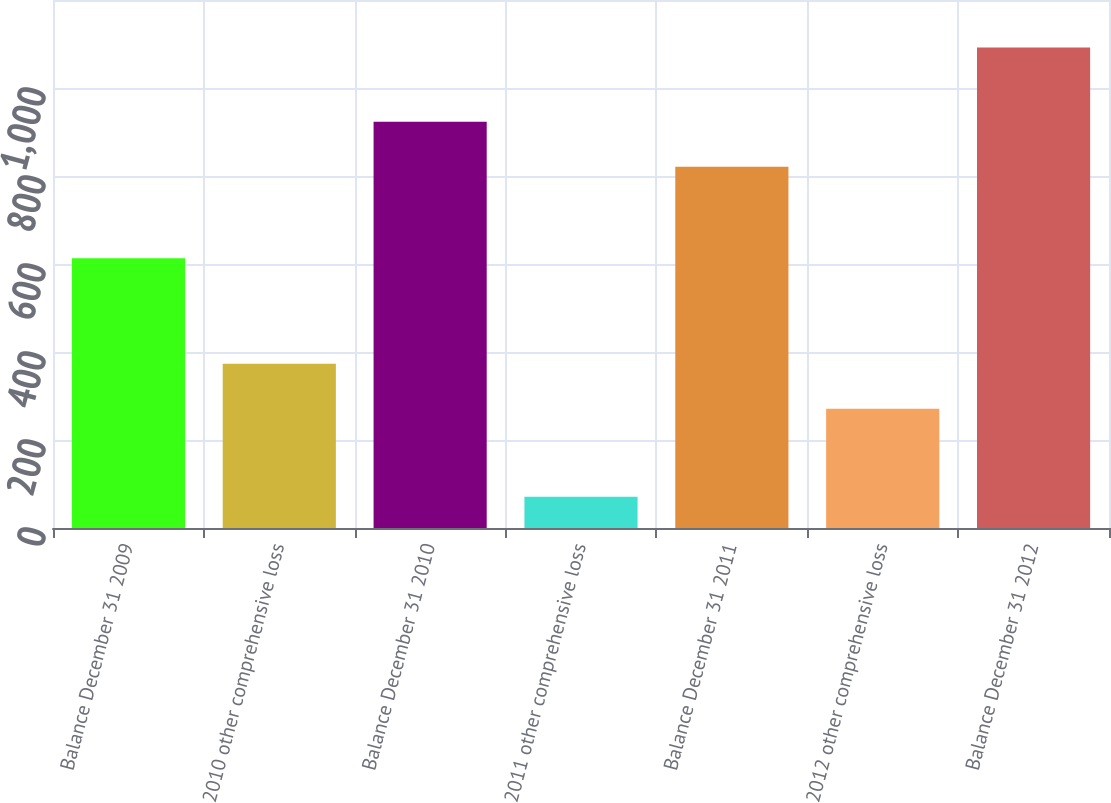Convert chart. <chart><loc_0><loc_0><loc_500><loc_500><bar_chart><fcel>Balance December 31 2009<fcel>2010 other comprehensive loss<fcel>Balance December 31 2010<fcel>2011 other comprehensive loss<fcel>Balance December 31 2011<fcel>2012 other comprehensive loss<fcel>Balance December 31 2012<nl><fcel>613<fcel>373.1<fcel>923.1<fcel>71<fcel>821<fcel>271<fcel>1092<nl></chart> 